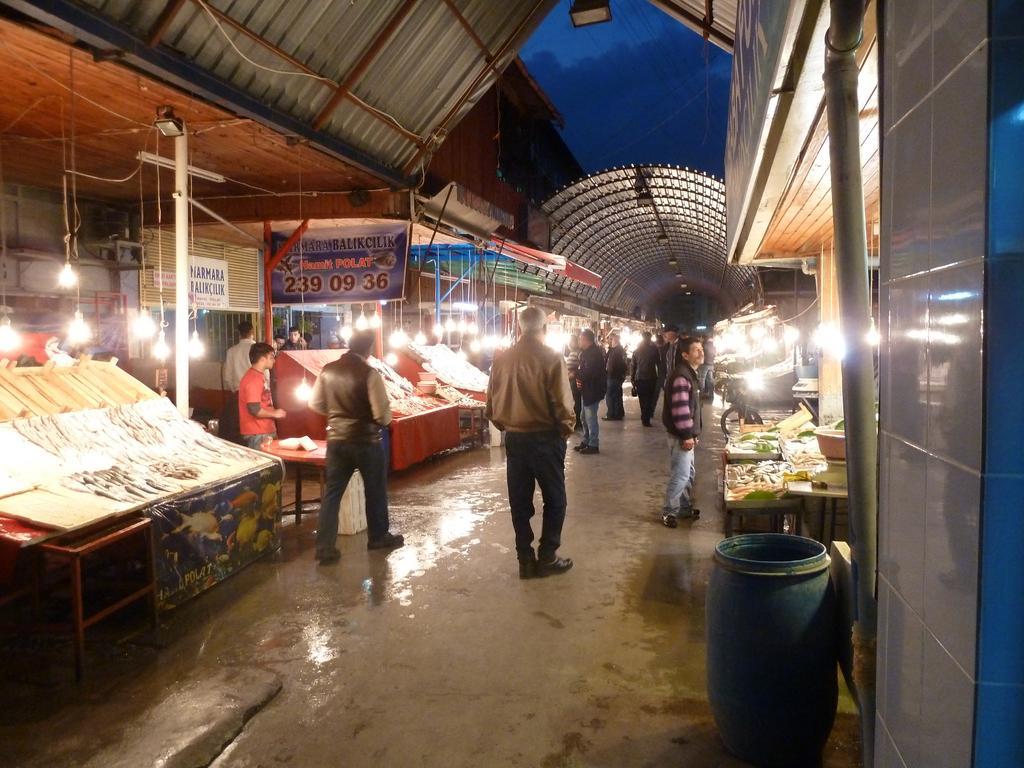Could you give a brief overview of what you see in this image? In this picture we can see group of people, beside to them we can see few things on the tables, and also we can see few lights, poles and hoardings, on the right side of the image we can see a pipe and a barrel. 